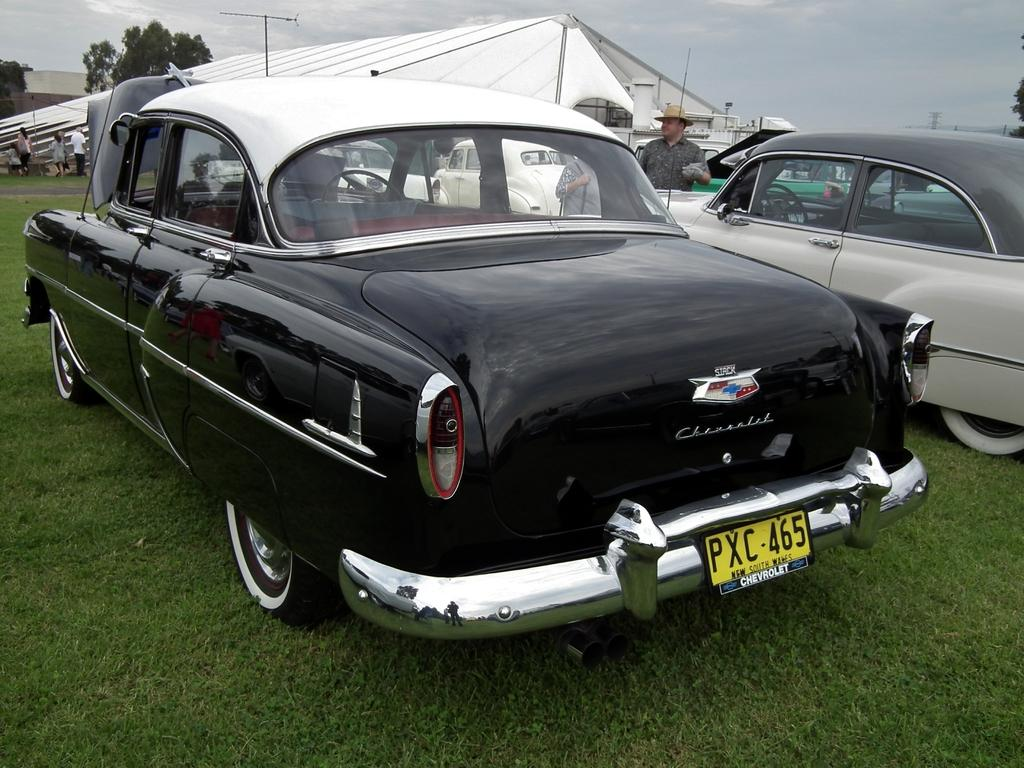What type of vehicles can be seen in the image? There are cars in the image. What type of natural environment is visible in the image? There is grass, trees, and the sky visible in the image. What type of structure is present in the image? There is a tent in the image. What else can be seen in the image besides the cars and natural environment? There are people and a pole in the image. Can you tell me which parent is holding the crying baby in the image? There is no baby present in the image, let alone a crying one, so it is not possible to identify a parent holding a baby. 